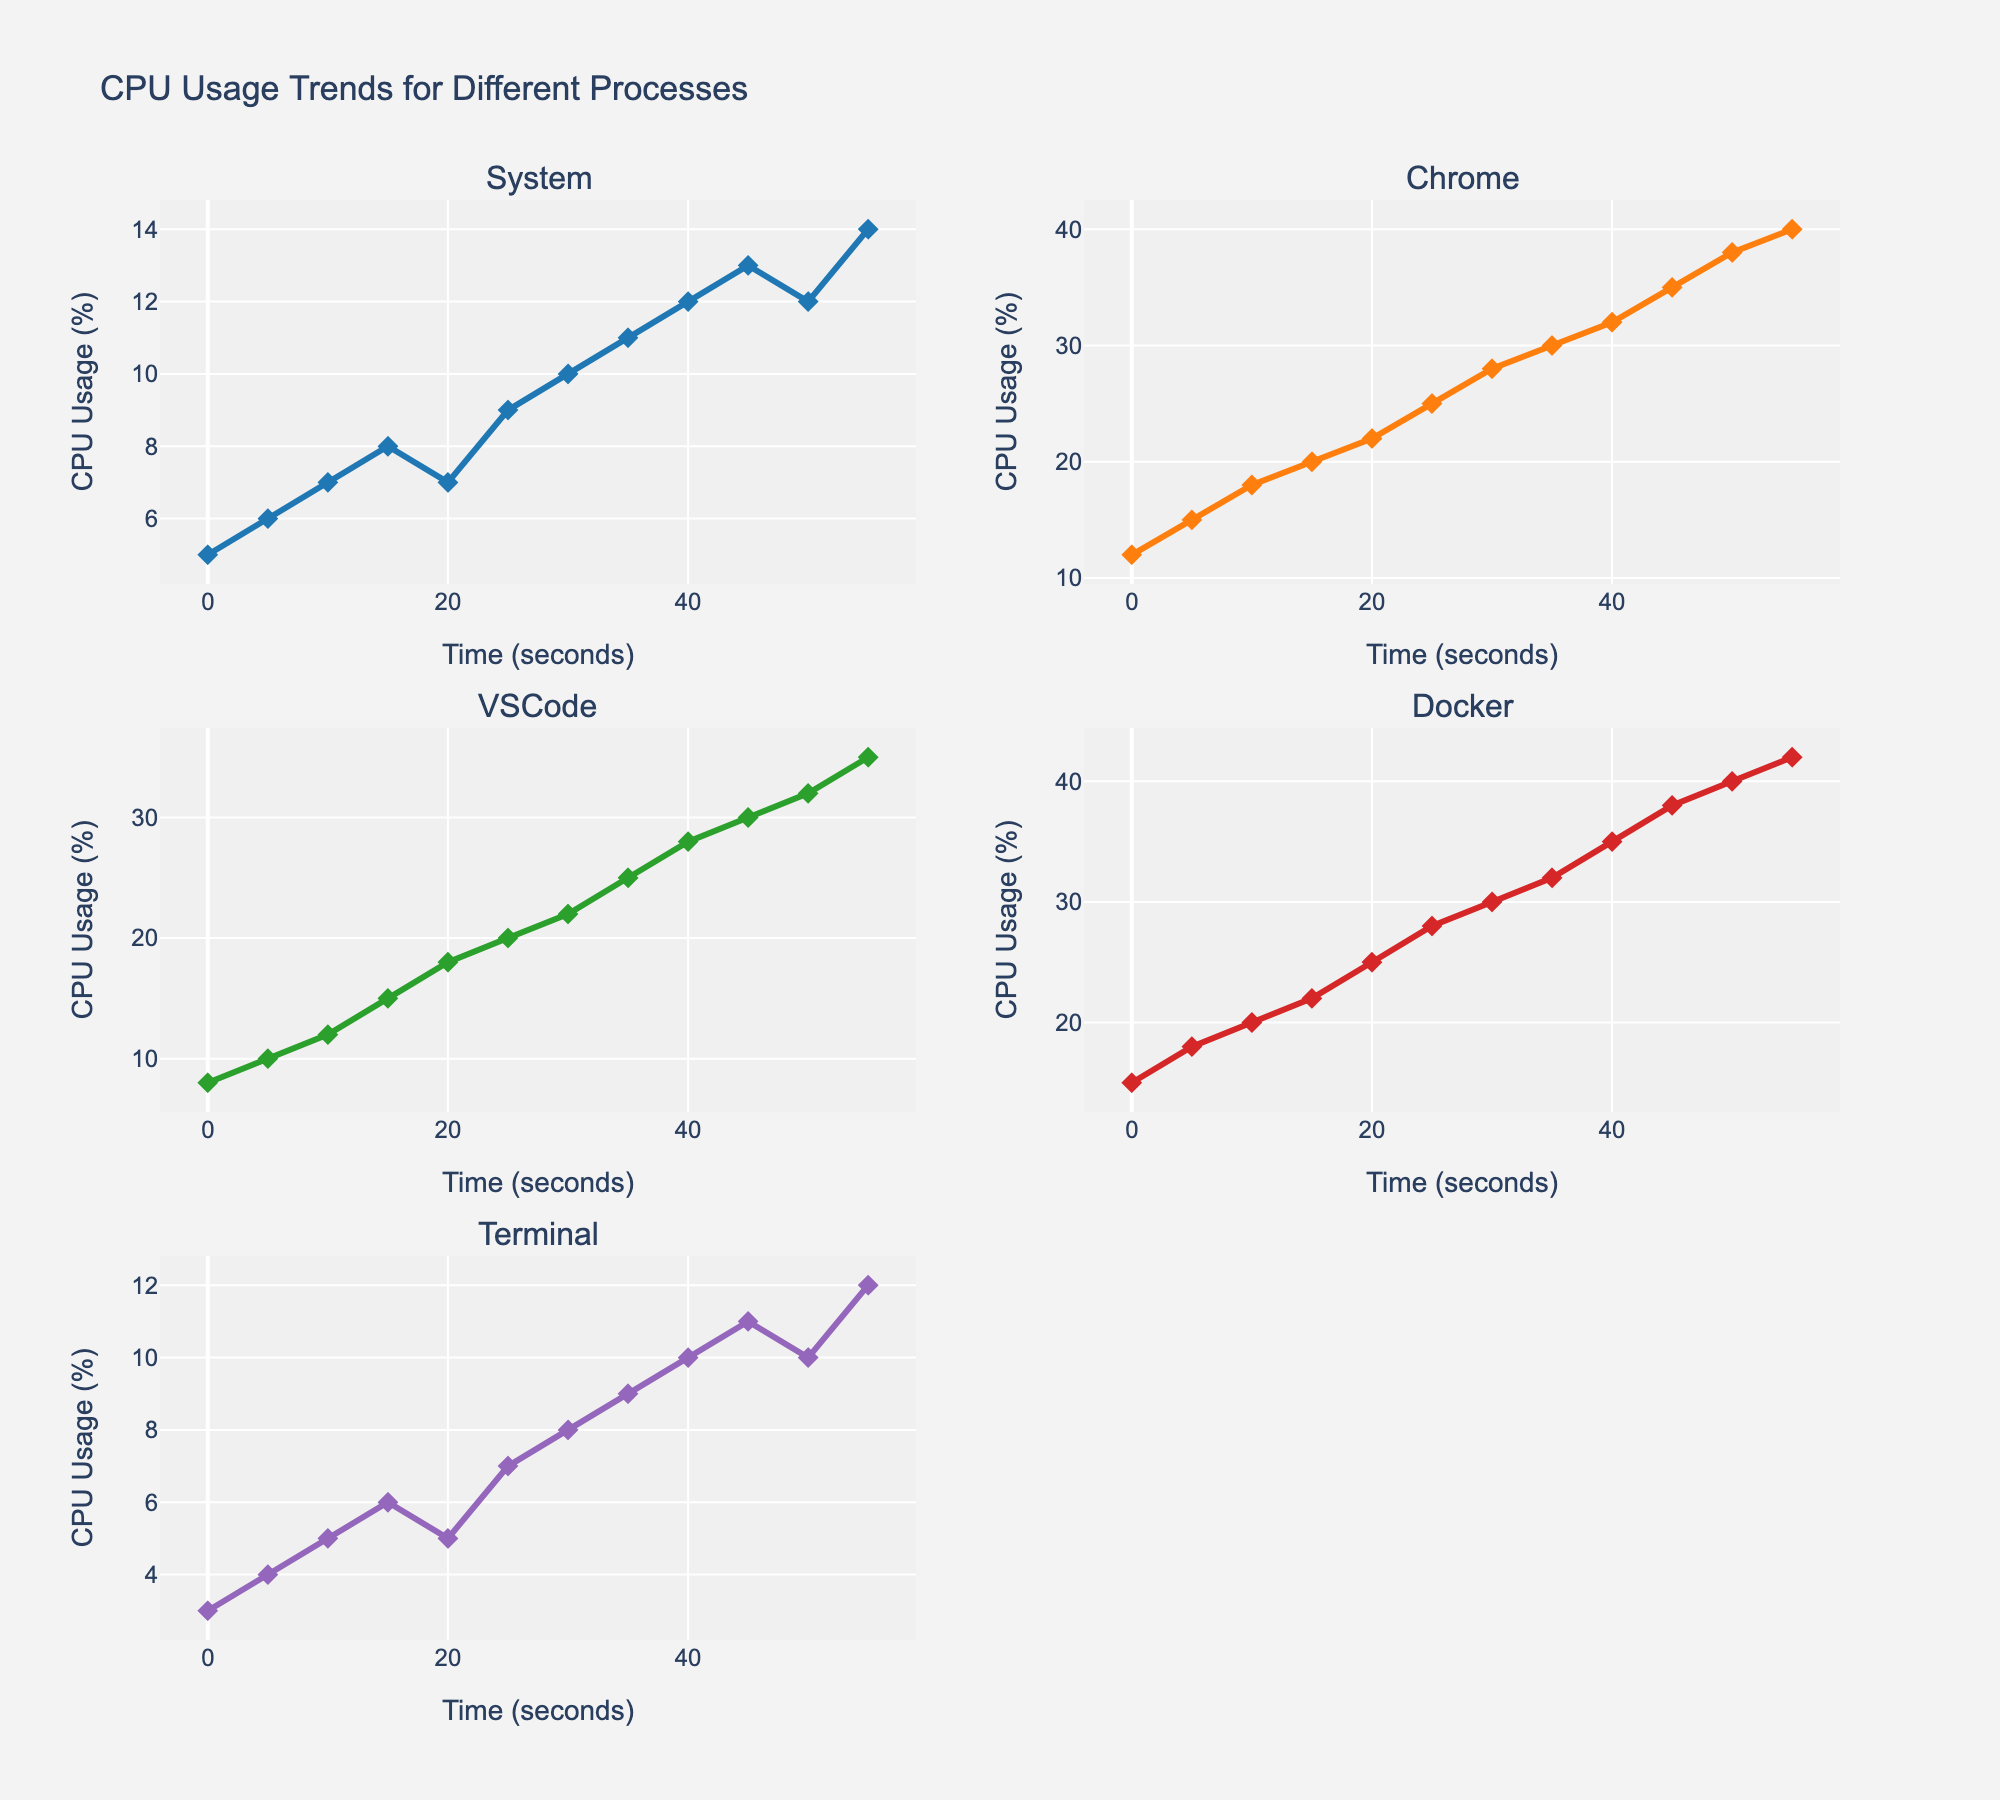What's the maximum CPU usage for the Chrome process? To find the maximum CPU usage for the Chrome process, look at the peak point on the Chrome subplot line chart. The highest point on the line for Chrome is 40%.
Answer: 40% How does the CPU usage of the VSCode process compare at the 10-second and 30-second marks? Observe the values on the VSCode subplot line chart at the 10-second and 30-second marks. At 10 seconds, the usage is 12%; at 30 seconds, it is 22%. The usage increased by 10%.
Answer: Increased by 10% Which process shows the most volatile CPU usage trend? The CPU usage trend is most volatile if the line graph fluctuates significantly. Docker's CPU usage shows the steepest and most frequent changes across the subplot, indicating volatility.
Answer: Docker What's the average CPU usage across all processes at the 25-second mark? Sum the CPU usage values at 25 seconds for all processes and divide by the number of processes. The values are 9 (System), 25 (Chrome), 20 (VSCode), 28 (Docker), and 7 (Terminal). The sum is 89, and the average is 89/5 = 17.8%.
Answer: 17.8% Between 15 and 35 seconds, which process has the smallest increase in CPU usage? Calculate the difference in CPU usage for each process between 15 and 35 seconds. System: 11-8=3, Chrome: 30-20=10, VSCode: 25-15=10, Docker: 32-22=10, Terminal: 9-6=3. The smallest increase is for System and Terminal, both with 3%.
Answer: System and Terminal At what time stamp do the Chrome and Terminal processes have the same CPU usage? Inspect the Chrome and Terminal subplot line charts to find the intersection point. Both show a CPU usage of 10% at the 40-second mark.
Answer: 40 seconds What's the trend in CPU usage for the System process? The System process shows a consistent upward trend in CPU usage over time, indicated by a steady rise in the line chart.
Answer: Upward trend Which process has the highest CPU usage at the 50-second mark? At the 50-second mark, compare the CPU usage values for each process. Docker shows the highest value at 40%.
Answer: Docker What is the total increase in CPU usage for the Terminal process from start to end? Subtract the initial CPU usage from the final value for the Terminal process. Initial value is 3%, and final value is 12%. The total increase is 12-3=9%.
Answer: 9% Are there any intervals of decreasing CPU usage for any process? If yes, which ones? Check each subplot to see if the CPU usage decreases over any time intervals. System decreases between 20 and 25 seconds (7% to 9%), and Terminal decreases between 50 and 55 seconds (10% to 12%).
Answer: System and Terminal 